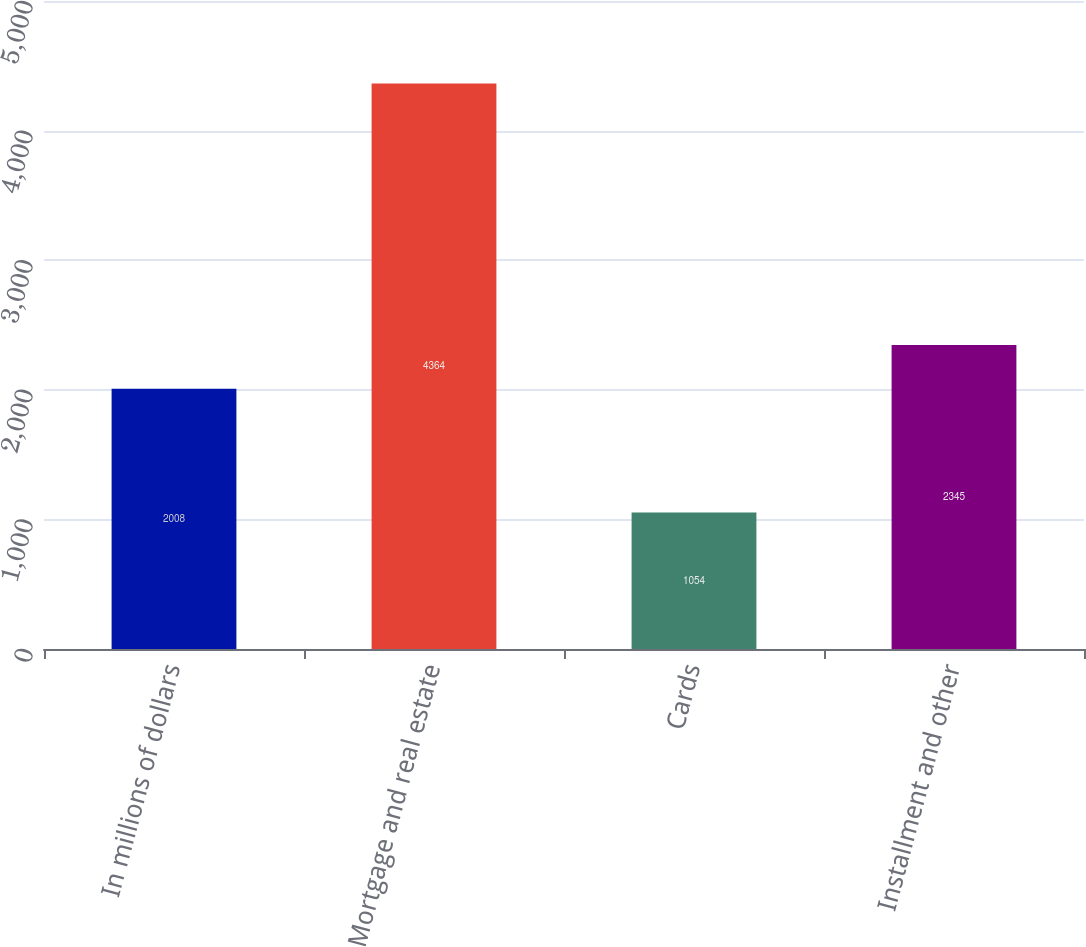<chart> <loc_0><loc_0><loc_500><loc_500><bar_chart><fcel>In millions of dollars<fcel>Mortgage and real estate<fcel>Cards<fcel>Installment and other<nl><fcel>2008<fcel>4364<fcel>1054<fcel>2345<nl></chart> 